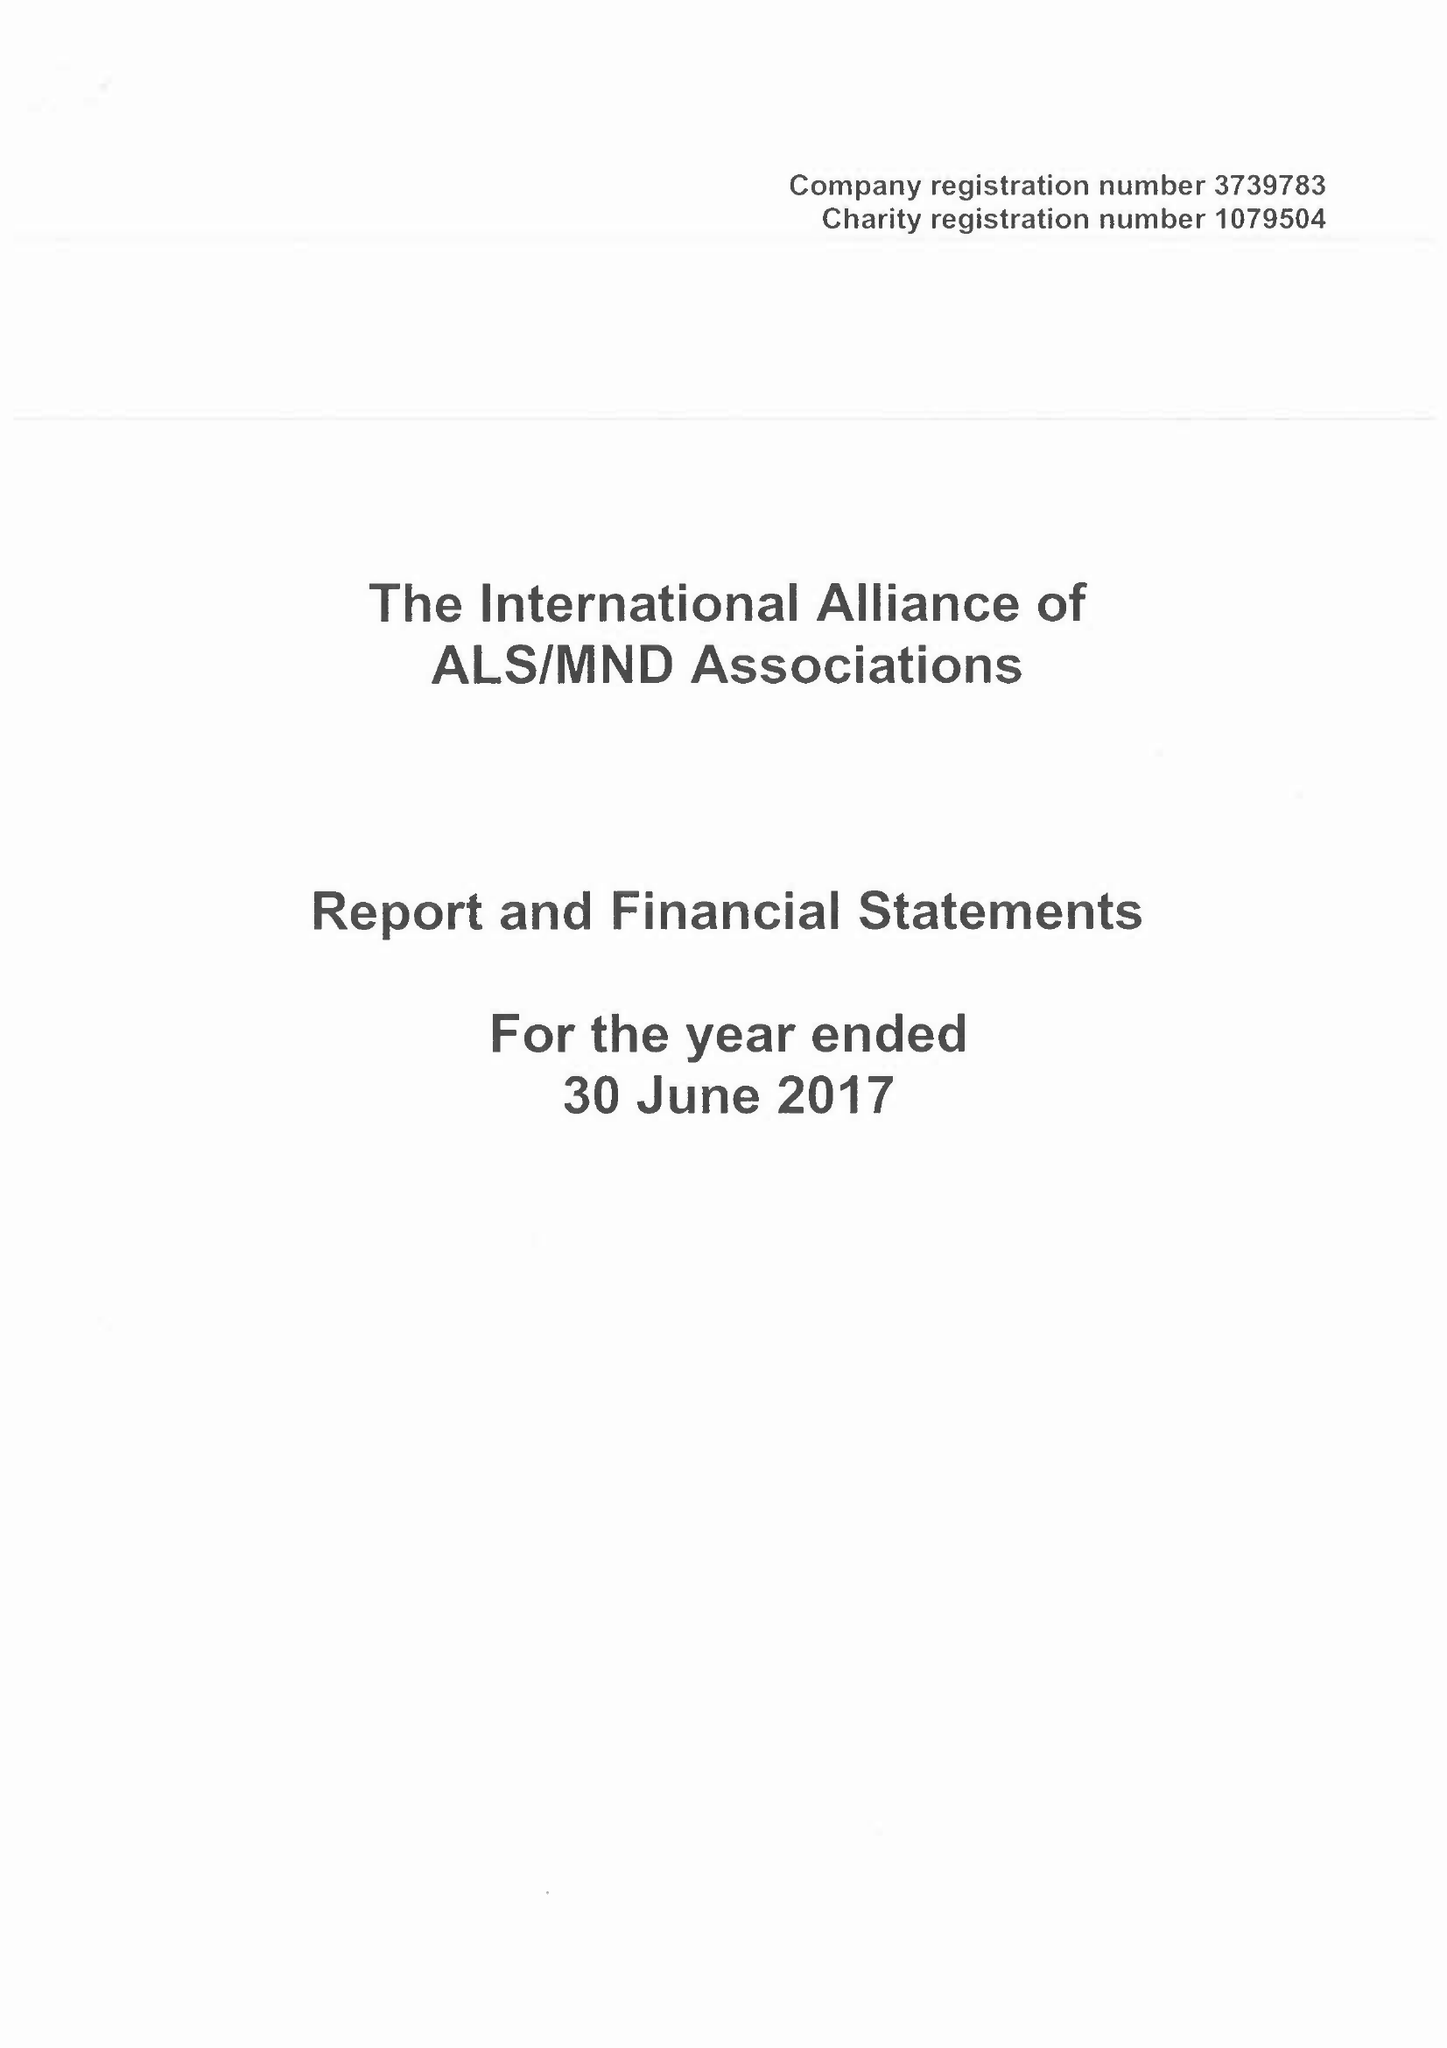What is the value for the address__post_town?
Answer the question using a single word or phrase. NORTHAMPTON 